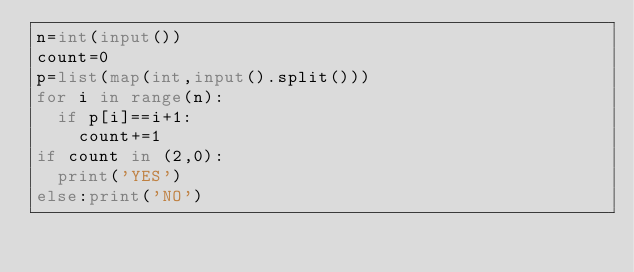<code> <loc_0><loc_0><loc_500><loc_500><_Python_>n=int(input())
count=0
p=list(map(int,input().split()))
for i in range(n):
  if p[i]==i+1:
    count+=1
if count in (2,0):
  print('YES')
else:print('NO')</code> 